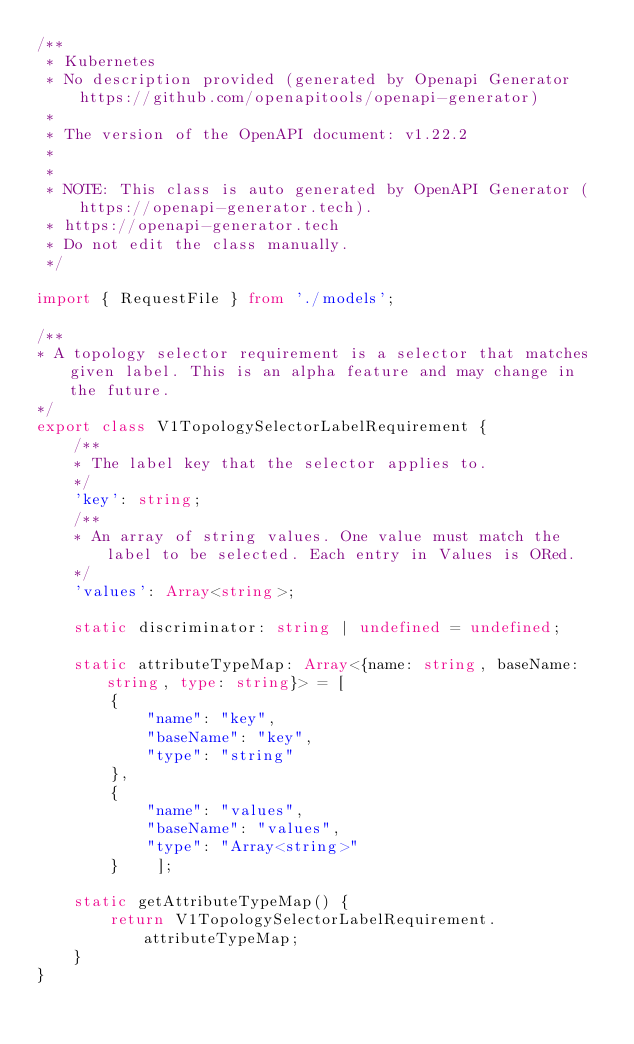Convert code to text. <code><loc_0><loc_0><loc_500><loc_500><_TypeScript_>/**
 * Kubernetes
 * No description provided (generated by Openapi Generator https://github.com/openapitools/openapi-generator)
 *
 * The version of the OpenAPI document: v1.22.2
 * 
 *
 * NOTE: This class is auto generated by OpenAPI Generator (https://openapi-generator.tech).
 * https://openapi-generator.tech
 * Do not edit the class manually.
 */

import { RequestFile } from './models';

/**
* A topology selector requirement is a selector that matches given label. This is an alpha feature and may change in the future.
*/
export class V1TopologySelectorLabelRequirement {
    /**
    * The label key that the selector applies to.
    */
    'key': string;
    /**
    * An array of string values. One value must match the label to be selected. Each entry in Values is ORed.
    */
    'values': Array<string>;

    static discriminator: string | undefined = undefined;

    static attributeTypeMap: Array<{name: string, baseName: string, type: string}> = [
        {
            "name": "key",
            "baseName": "key",
            "type": "string"
        },
        {
            "name": "values",
            "baseName": "values",
            "type": "Array<string>"
        }    ];

    static getAttributeTypeMap() {
        return V1TopologySelectorLabelRequirement.attributeTypeMap;
    }
}

</code> 